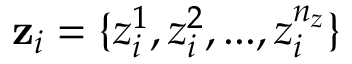<formula> <loc_0><loc_0><loc_500><loc_500>z _ { i } = \{ z _ { i } ^ { 1 } , z _ { i } ^ { 2 } , \dots , z _ { i } ^ { n _ { z } } \}</formula> 